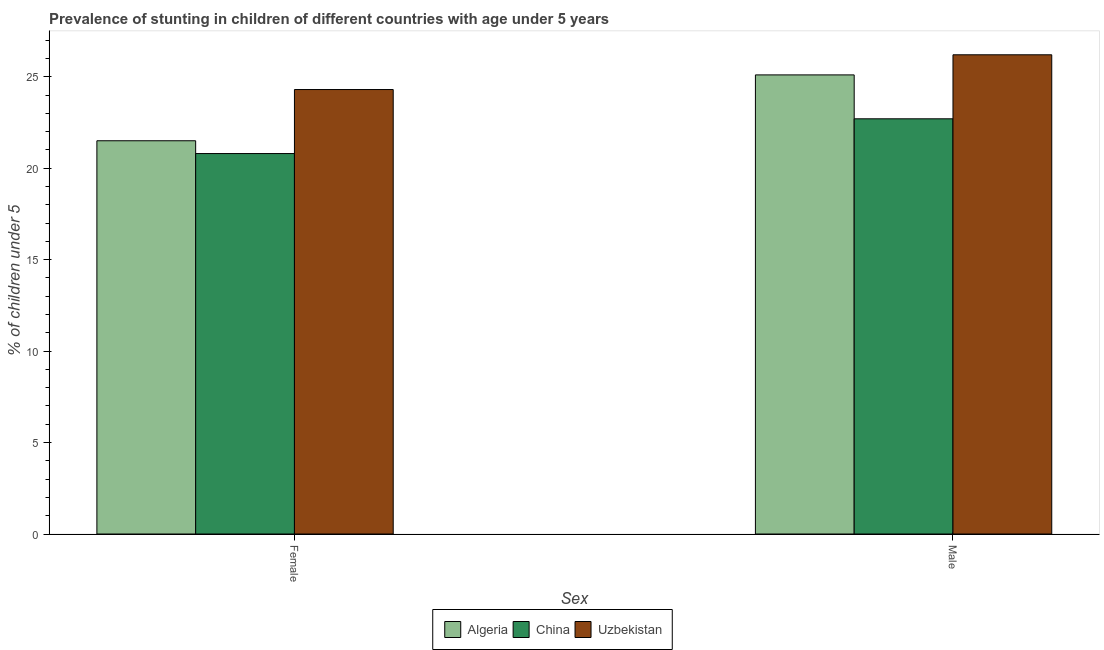How many groups of bars are there?
Your answer should be very brief. 2. What is the label of the 2nd group of bars from the left?
Make the answer very short. Male. What is the percentage of stunted female children in China?
Give a very brief answer. 20.8. Across all countries, what is the maximum percentage of stunted female children?
Offer a very short reply. 24.3. Across all countries, what is the minimum percentage of stunted female children?
Ensure brevity in your answer.  20.8. In which country was the percentage of stunted female children maximum?
Offer a very short reply. Uzbekistan. What is the total percentage of stunted male children in the graph?
Keep it short and to the point. 74. What is the difference between the percentage of stunted female children in Uzbekistan and that in Algeria?
Ensure brevity in your answer.  2.8. What is the difference between the percentage of stunted female children in Algeria and the percentage of stunted male children in China?
Make the answer very short. -1.2. What is the average percentage of stunted female children per country?
Offer a terse response. 22.2. What is the difference between the percentage of stunted female children and percentage of stunted male children in Algeria?
Offer a terse response. -3.6. In how many countries, is the percentage of stunted male children greater than 2 %?
Make the answer very short. 3. What is the ratio of the percentage of stunted male children in China to that in Algeria?
Make the answer very short. 0.9. What does the 2nd bar from the left in Male represents?
Your response must be concise. China. What does the 3rd bar from the right in Female represents?
Ensure brevity in your answer.  Algeria. How many bars are there?
Offer a terse response. 6. Are the values on the major ticks of Y-axis written in scientific E-notation?
Give a very brief answer. No. Does the graph contain any zero values?
Your response must be concise. No. Does the graph contain grids?
Ensure brevity in your answer.  No. Where does the legend appear in the graph?
Offer a terse response. Bottom center. How are the legend labels stacked?
Keep it short and to the point. Horizontal. What is the title of the graph?
Keep it short and to the point. Prevalence of stunting in children of different countries with age under 5 years. What is the label or title of the X-axis?
Offer a very short reply. Sex. What is the label or title of the Y-axis?
Offer a very short reply.  % of children under 5. What is the  % of children under 5 in China in Female?
Keep it short and to the point. 20.8. What is the  % of children under 5 in Uzbekistan in Female?
Make the answer very short. 24.3. What is the  % of children under 5 of Algeria in Male?
Offer a terse response. 25.1. What is the  % of children under 5 in China in Male?
Keep it short and to the point. 22.7. What is the  % of children under 5 of Uzbekistan in Male?
Offer a terse response. 26.2. Across all Sex, what is the maximum  % of children under 5 in Algeria?
Your response must be concise. 25.1. Across all Sex, what is the maximum  % of children under 5 in China?
Offer a very short reply. 22.7. Across all Sex, what is the maximum  % of children under 5 of Uzbekistan?
Your answer should be very brief. 26.2. Across all Sex, what is the minimum  % of children under 5 of Algeria?
Give a very brief answer. 21.5. Across all Sex, what is the minimum  % of children under 5 of China?
Your answer should be very brief. 20.8. Across all Sex, what is the minimum  % of children under 5 in Uzbekistan?
Give a very brief answer. 24.3. What is the total  % of children under 5 in Algeria in the graph?
Offer a very short reply. 46.6. What is the total  % of children under 5 of China in the graph?
Offer a very short reply. 43.5. What is the total  % of children under 5 in Uzbekistan in the graph?
Provide a succinct answer. 50.5. What is the difference between the  % of children under 5 of China in Female and that in Male?
Your response must be concise. -1.9. What is the difference between the  % of children under 5 in China in Female and the  % of children under 5 in Uzbekistan in Male?
Your answer should be compact. -5.4. What is the average  % of children under 5 in Algeria per Sex?
Provide a short and direct response. 23.3. What is the average  % of children under 5 in China per Sex?
Ensure brevity in your answer.  21.75. What is the average  % of children under 5 in Uzbekistan per Sex?
Make the answer very short. 25.25. What is the difference between the  % of children under 5 of Algeria and  % of children under 5 of Uzbekistan in Female?
Provide a short and direct response. -2.8. What is the difference between the  % of children under 5 in China and  % of children under 5 in Uzbekistan in Male?
Your answer should be very brief. -3.5. What is the ratio of the  % of children under 5 in Algeria in Female to that in Male?
Your answer should be very brief. 0.86. What is the ratio of the  % of children under 5 of China in Female to that in Male?
Offer a very short reply. 0.92. What is the ratio of the  % of children under 5 of Uzbekistan in Female to that in Male?
Make the answer very short. 0.93. What is the difference between the highest and the second highest  % of children under 5 in Algeria?
Keep it short and to the point. 3.6. What is the difference between the highest and the second highest  % of children under 5 of Uzbekistan?
Your answer should be compact. 1.9. What is the difference between the highest and the lowest  % of children under 5 in Algeria?
Offer a terse response. 3.6. What is the difference between the highest and the lowest  % of children under 5 of China?
Your response must be concise. 1.9. What is the difference between the highest and the lowest  % of children under 5 of Uzbekistan?
Your response must be concise. 1.9. 